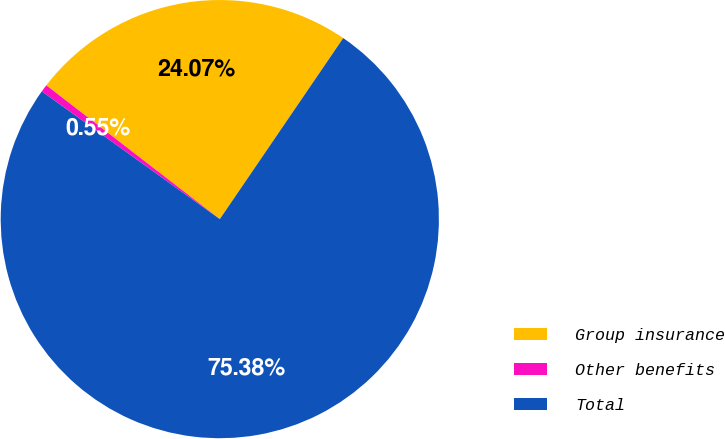Convert chart to OTSL. <chart><loc_0><loc_0><loc_500><loc_500><pie_chart><fcel>Group insurance<fcel>Other benefits<fcel>Total<nl><fcel>24.07%<fcel>0.55%<fcel>75.39%<nl></chart> 